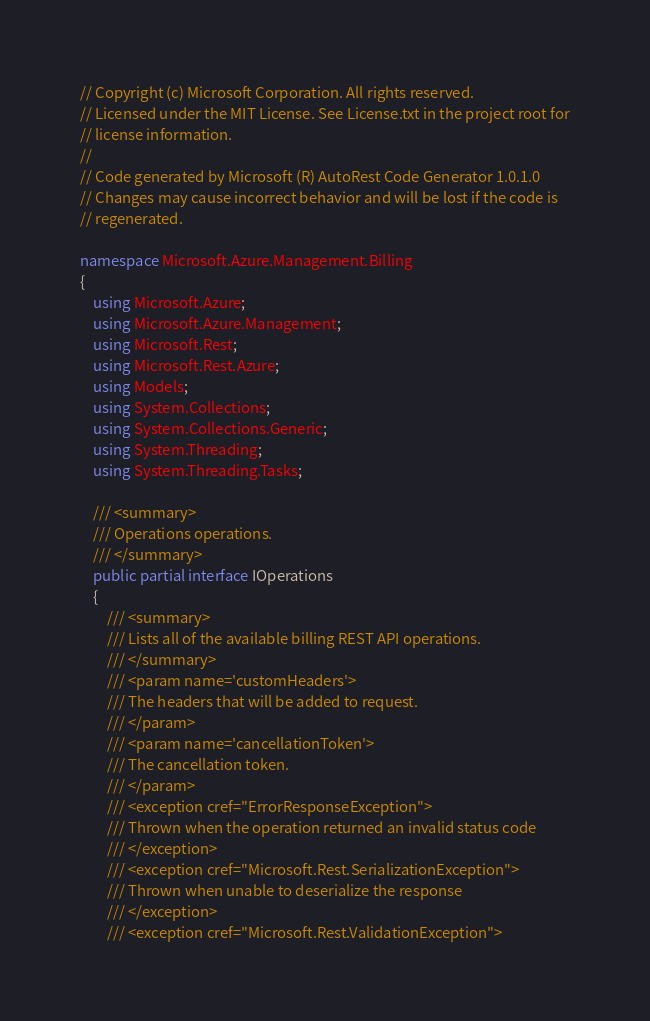Convert code to text. <code><loc_0><loc_0><loc_500><loc_500><_C#_>// Copyright (c) Microsoft Corporation. All rights reserved.
// Licensed under the MIT License. See License.txt in the project root for
// license information.
//
// Code generated by Microsoft (R) AutoRest Code Generator 1.0.1.0
// Changes may cause incorrect behavior and will be lost if the code is
// regenerated.

namespace Microsoft.Azure.Management.Billing
{
    using Microsoft.Azure;
    using Microsoft.Azure.Management;
    using Microsoft.Rest;
    using Microsoft.Rest.Azure;
    using Models;
    using System.Collections;
    using System.Collections.Generic;
    using System.Threading;
    using System.Threading.Tasks;

    /// <summary>
    /// Operations operations.
    /// </summary>
    public partial interface IOperations
    {
        /// <summary>
        /// Lists all of the available billing REST API operations.
        /// </summary>
        /// <param name='customHeaders'>
        /// The headers that will be added to request.
        /// </param>
        /// <param name='cancellationToken'>
        /// The cancellation token.
        /// </param>
        /// <exception cref="ErrorResponseException">
        /// Thrown when the operation returned an invalid status code
        /// </exception>
        /// <exception cref="Microsoft.Rest.SerializationException">
        /// Thrown when unable to deserialize the response
        /// </exception>
        /// <exception cref="Microsoft.Rest.ValidationException"></code> 